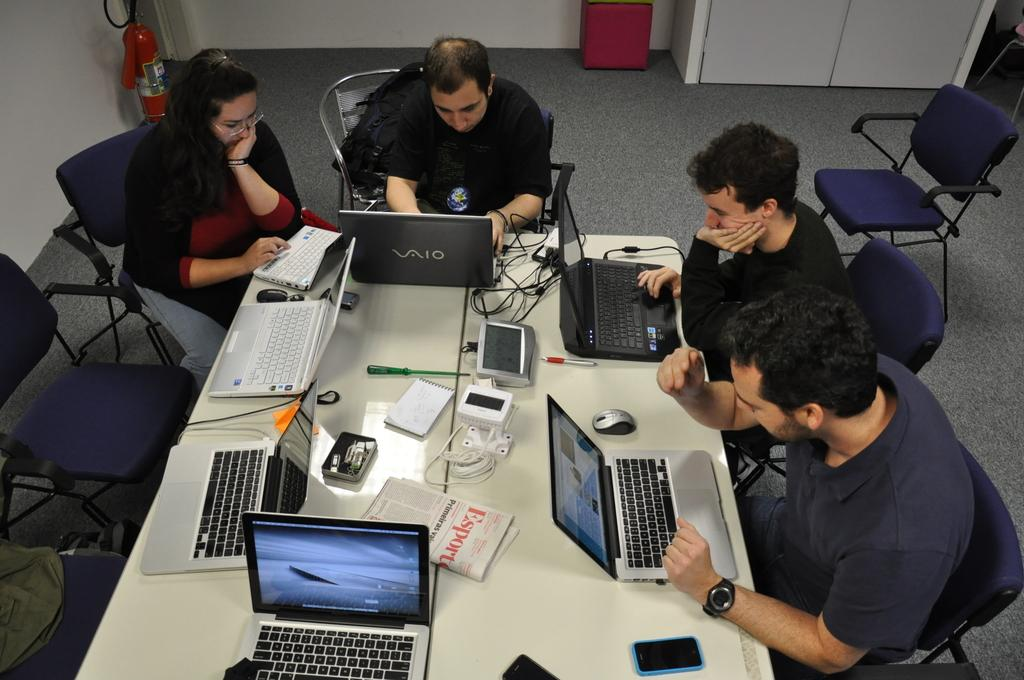<image>
Render a clear and concise summary of the photo. a man using a Vaio laptop working with three other people 